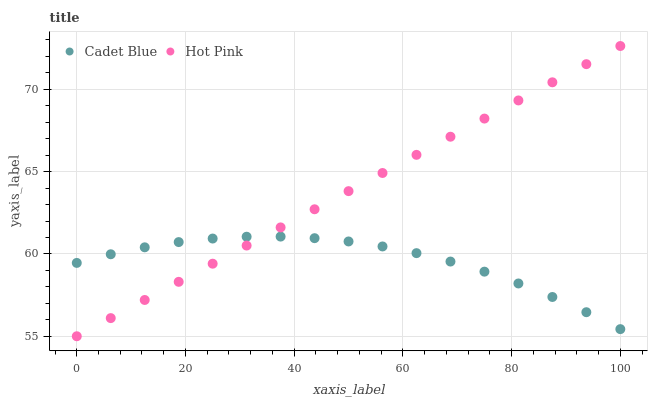Does Cadet Blue have the minimum area under the curve?
Answer yes or no. Yes. Does Hot Pink have the maximum area under the curve?
Answer yes or no. Yes. Does Hot Pink have the minimum area under the curve?
Answer yes or no. No. Is Hot Pink the smoothest?
Answer yes or no. Yes. Is Cadet Blue the roughest?
Answer yes or no. Yes. Is Hot Pink the roughest?
Answer yes or no. No. Does Hot Pink have the lowest value?
Answer yes or no. Yes. Does Hot Pink have the highest value?
Answer yes or no. Yes. Does Hot Pink intersect Cadet Blue?
Answer yes or no. Yes. Is Hot Pink less than Cadet Blue?
Answer yes or no. No. Is Hot Pink greater than Cadet Blue?
Answer yes or no. No. 